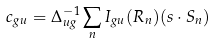<formula> <loc_0><loc_0><loc_500><loc_500>c _ { g u } = \Delta _ { u g } ^ { - 1 } \sum _ { n } I _ { g u } ( { R } _ { n } ) ( { s } \cdot { S } _ { n } )</formula> 